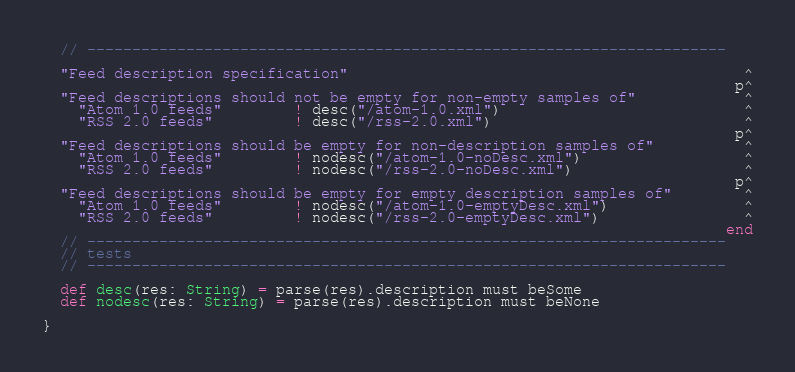<code> <loc_0><loc_0><loc_500><loc_500><_Scala_>  // -----------------------------------------------------------------------

  "Feed description specification"                                            ^
                                                                             p^
  "Feed descriptions should not be empty for non-empty samples of"            ^
    "Atom 1.0 feeds"        ! desc("/atom-1.0.xml")                           ^
    "RSS 2.0 feeds"         ! desc("/rss-2.0.xml")                            ^
                                                                             p^
  "Feed descriptions should be empty for non-description samples of"          ^
    "Atom 1.0 feeds"        ! nodesc("/atom-1.0-noDesc.xml")                  ^
    "RSS 2.0 feeds"         ! nodesc("/rss-2.0-noDesc.xml")                   ^
                                                                             p^
  "Feed descriptions should be empty for empty description samples of"        ^
    "Atom 1.0 feeds"        ! nodesc("/atom-1.0-emptyDesc.xml")               ^
    "RSS 2.0 feeds"         ! nodesc("/rss-2.0-emptyDesc.xml")                ^
                                                                            end
  // -----------------------------------------------------------------------
  // tests
  // -----------------------------------------------------------------------

  def desc(res: String) = parse(res).description must beSome
  def nodesc(res: String) = parse(res).description must beNone

}
</code> 